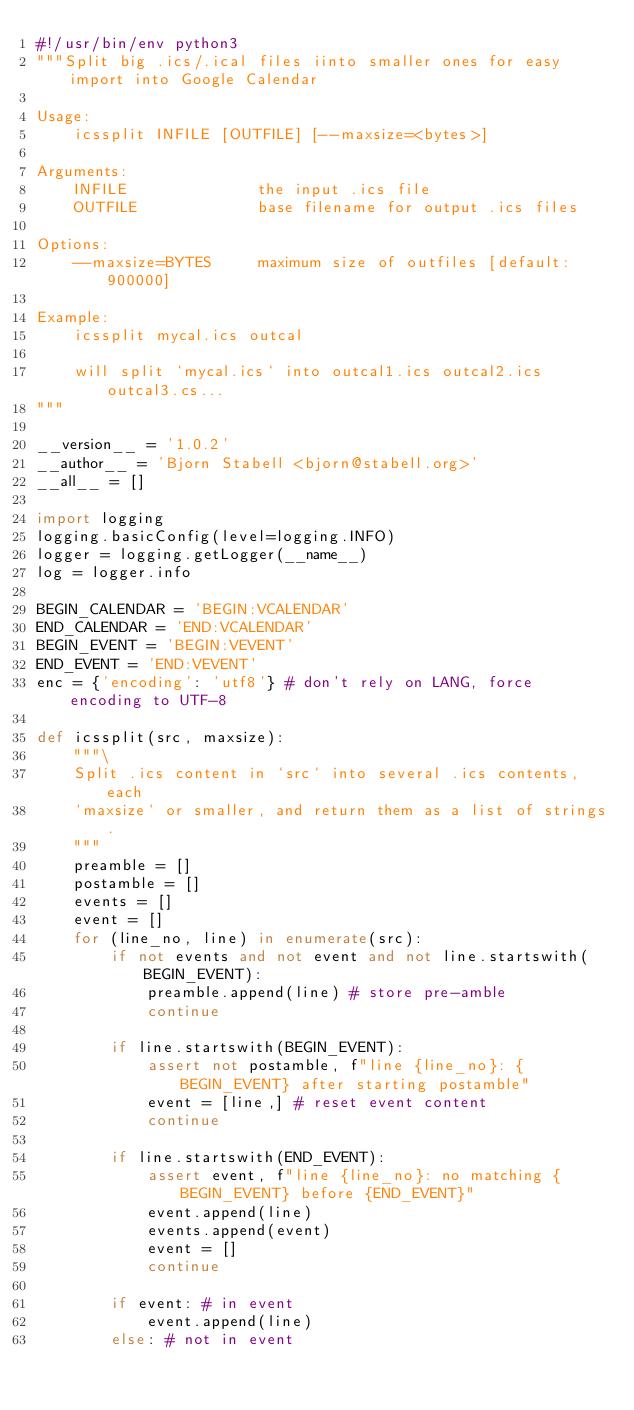Convert code to text. <code><loc_0><loc_0><loc_500><loc_500><_Python_>#!/usr/bin/env python3
"""Split big .ics/.ical files iinto smaller ones for easy import into Google Calendar

Usage:
	icssplit INFILE [OUTFILE] [--maxsize=<bytes>]

Arguments:
	INFILE				the input .ics file
	OUTFILE				base filename for output .ics files

Options:
	--maxsize=BYTES		maximum size of outfiles [default: 900000]

Example:
	icssplit mycal.ics outcal

 	will split `mycal.ics` into outcal1.ics outcal2.ics outcal3.cs...
"""

__version__ = '1.0.2'
__author__ = 'Bjorn Stabell <bjorn@stabell.org>'
__all__ = []

import logging
logging.basicConfig(level=logging.INFO)
logger = logging.getLogger(__name__)
log = logger.info

BEGIN_CALENDAR = 'BEGIN:VCALENDAR'
END_CALENDAR = 'END:VCALENDAR'
BEGIN_EVENT = 'BEGIN:VEVENT'
END_EVENT = 'END:VEVENT'
enc = {'encoding': 'utf8'} # don't rely on LANG, force encoding to UTF-8

def icssplit(src, maxsize):
	"""\
	Split .ics content in `src` into several .ics contents, each
	`maxsize` or smaller, and return them as a list of strings.
	"""
	preamble = []
	postamble = []
	events = []
	event = []
	for (line_no, line) in enumerate(src):
		if not events and not event and not line.startswith(BEGIN_EVENT):
			preamble.append(line) # store pre-amble
			continue

		if line.startswith(BEGIN_EVENT):
			assert not postamble, f"line {line_no}: {BEGIN_EVENT} after starting postamble"
			event = [line,]	# reset event content
			continue

		if line.startswith(END_EVENT):
			assert event, f"line {line_no}: no matching {BEGIN_EVENT} before {END_EVENT}"
			event.append(line)
			events.append(event)
			event = []
			continue

		if event: # in event
			event.append(line)
		else: # not in event</code> 